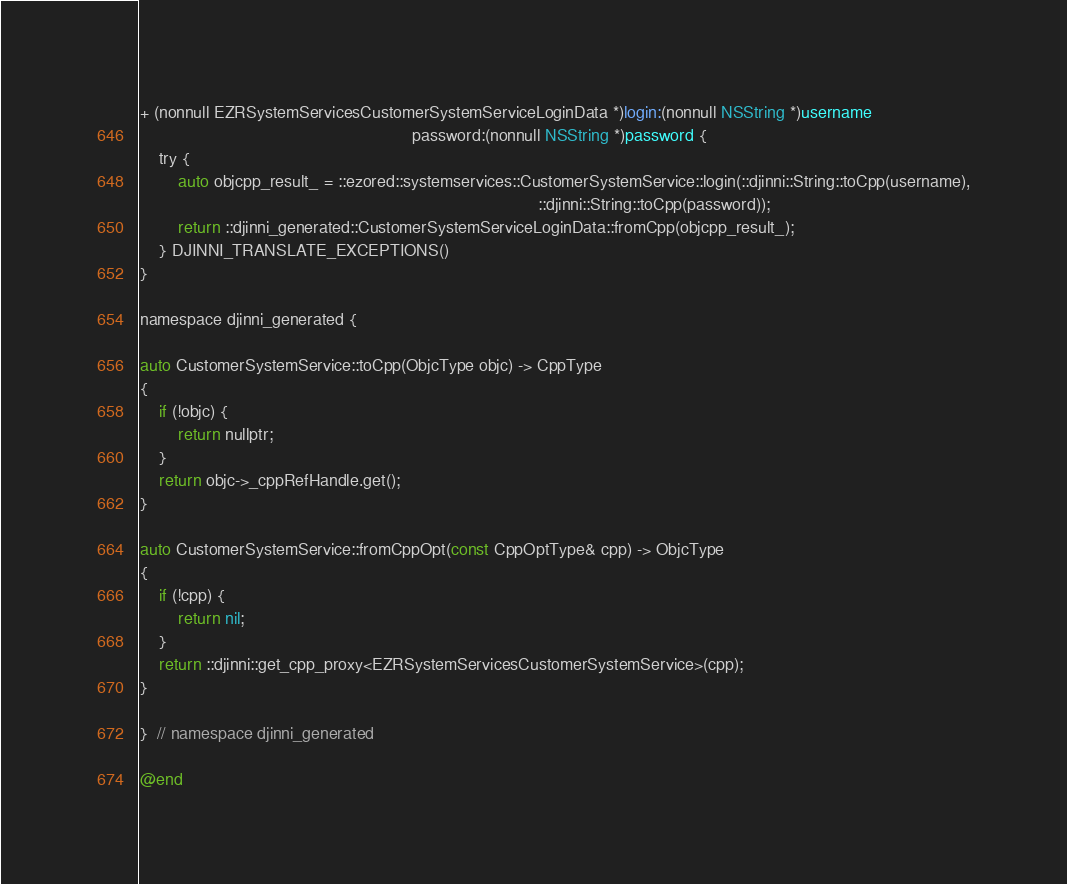<code> <loc_0><loc_0><loc_500><loc_500><_ObjectiveC_>
+ (nonnull EZRSystemServicesCustomerSystemServiceLoginData *)login:(nonnull NSString *)username
                                                          password:(nonnull NSString *)password {
    try {
        auto objcpp_result_ = ::ezored::systemservices::CustomerSystemService::login(::djinni::String::toCpp(username),
                                                                                     ::djinni::String::toCpp(password));
        return ::djinni_generated::CustomerSystemServiceLoginData::fromCpp(objcpp_result_);
    } DJINNI_TRANSLATE_EXCEPTIONS()
}

namespace djinni_generated {

auto CustomerSystemService::toCpp(ObjcType objc) -> CppType
{
    if (!objc) {
        return nullptr;
    }
    return objc->_cppRefHandle.get();
}

auto CustomerSystemService::fromCppOpt(const CppOptType& cpp) -> ObjcType
{
    if (!cpp) {
        return nil;
    }
    return ::djinni::get_cpp_proxy<EZRSystemServicesCustomerSystemService>(cpp);
}

}  // namespace djinni_generated

@end
</code> 